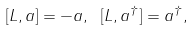<formula> <loc_0><loc_0><loc_500><loc_500>[ L , a ] = - a , \ [ L , a ^ { \dagger } ] = a ^ { \dagger } ,</formula> 